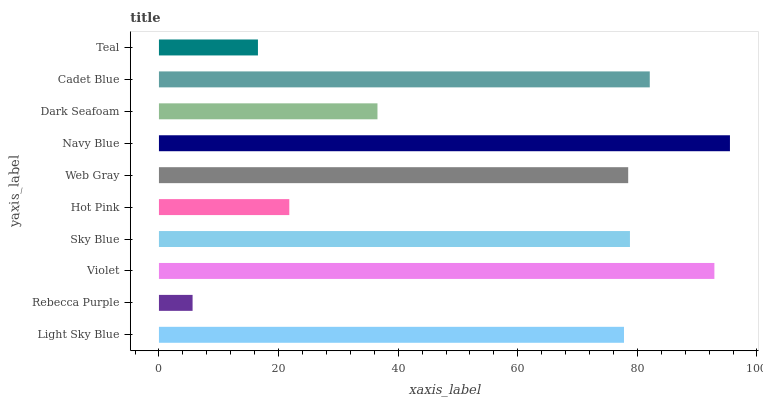Is Rebecca Purple the minimum?
Answer yes or no. Yes. Is Navy Blue the maximum?
Answer yes or no. Yes. Is Violet the minimum?
Answer yes or no. No. Is Violet the maximum?
Answer yes or no. No. Is Violet greater than Rebecca Purple?
Answer yes or no. Yes. Is Rebecca Purple less than Violet?
Answer yes or no. Yes. Is Rebecca Purple greater than Violet?
Answer yes or no. No. Is Violet less than Rebecca Purple?
Answer yes or no. No. Is Web Gray the high median?
Answer yes or no. Yes. Is Light Sky Blue the low median?
Answer yes or no. Yes. Is Navy Blue the high median?
Answer yes or no. No. Is Dark Seafoam the low median?
Answer yes or no. No. 